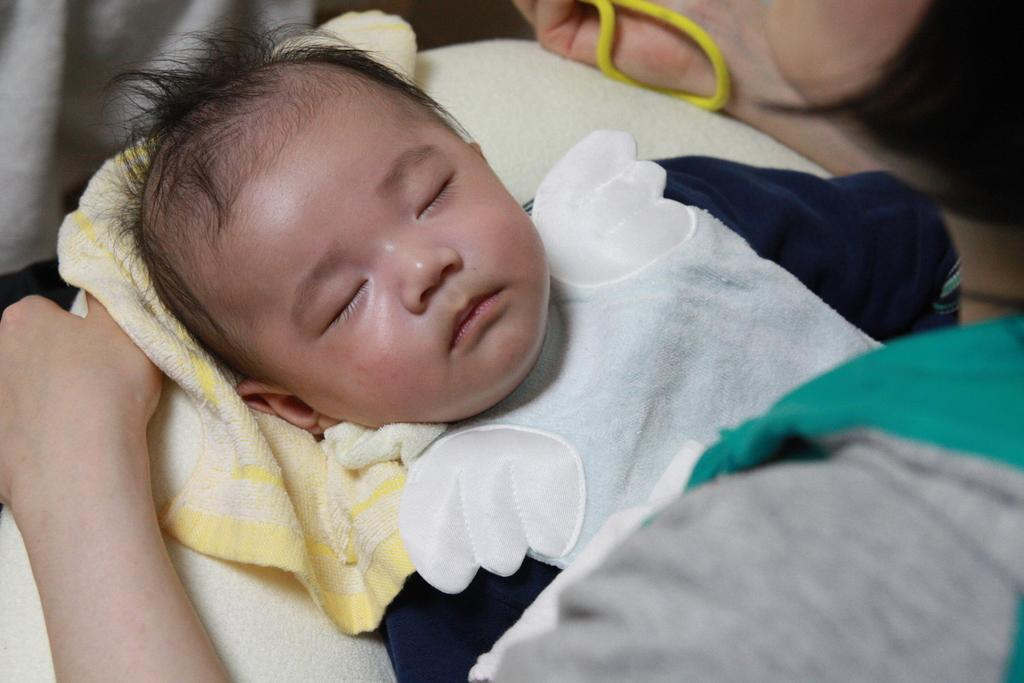What is the main subject of the image? There is a baby sleeping on the bed in the image. Can you describe the person on the right side of the image? The person is not clearly visible or described in the provided facts. What is the cloth at the top left side of the image used for? The purpose of the cloth at the top left side of the image is not mentioned in the provided facts. What type of coal is being mined by the father in the image? There is no father or coal mine present in the image; it features a baby sleeping on a bed and a cloth at the top left side. 